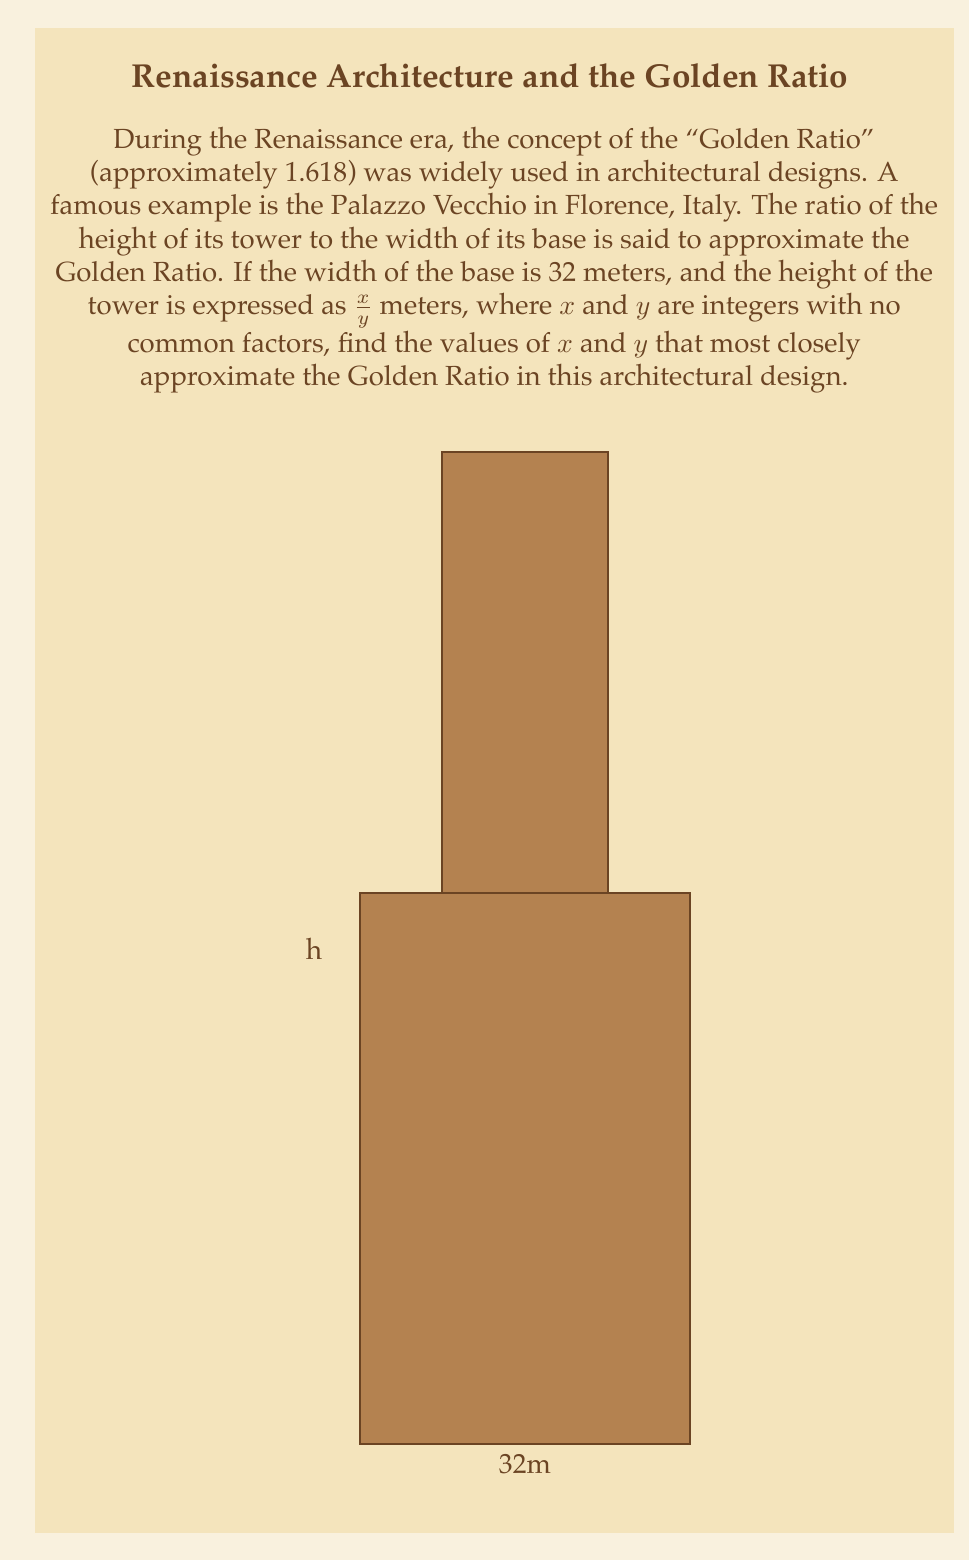Can you answer this question? Let's approach this step-by-step:

1) The Golden Ratio is approximately 1.618. We need to find a fraction $\frac{x}{y}$ that, when divided by 32, is close to 1.618.

2) This means we need to solve the equation:

   $$\frac{\frac{x}{y}}{32} \approx 1.618$$

3) Simplifying this equation:

   $$\frac{x}{32y} \approx 1.618$$

4) Cross-multiplying:

   $$x \approx 1.618 * 32y = 51.776y$$

5) We need to find integer values for $x$ and $y$ that satisfy this relationship as closely as possible. Let's try some values:

   For $y = 1$: $x \approx 51.776$ (too far from an integer)
   For $y = 2$: $x \approx 103.552$ (closer, but still not ideal)
   For $y = 3$: $x \approx 155.328$ (very close to 155)

6) Therefore, the fraction $\frac{155}{3}$ seems to be a good approximation.

7) Let's check:

   $$\frac{155}{3*32} \approx 1.6145833$$

   This is indeed very close to 1.618.

8) The height of the tower would thus be $\frac{155}{3} = 51\frac{2}{3}$ meters.
Answer: $x = 155$, $y = 3$ 